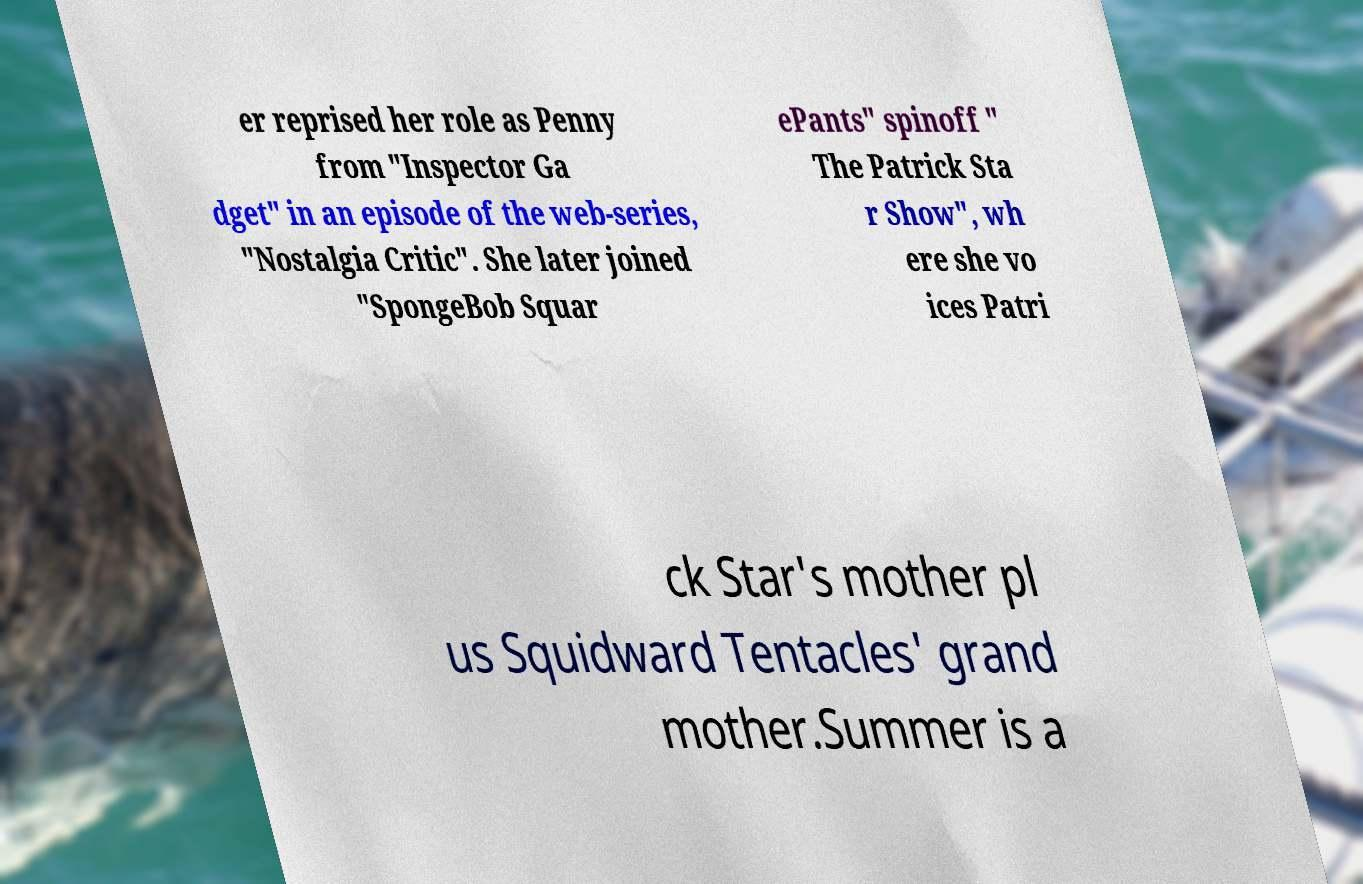Can you accurately transcribe the text from the provided image for me? er reprised her role as Penny from "Inspector Ga dget" in an episode of the web-series, "Nostalgia Critic". She later joined "SpongeBob Squar ePants" spinoff " The Patrick Sta r Show", wh ere she vo ices Patri ck Star's mother pl us Squidward Tentacles' grand mother.Summer is a 